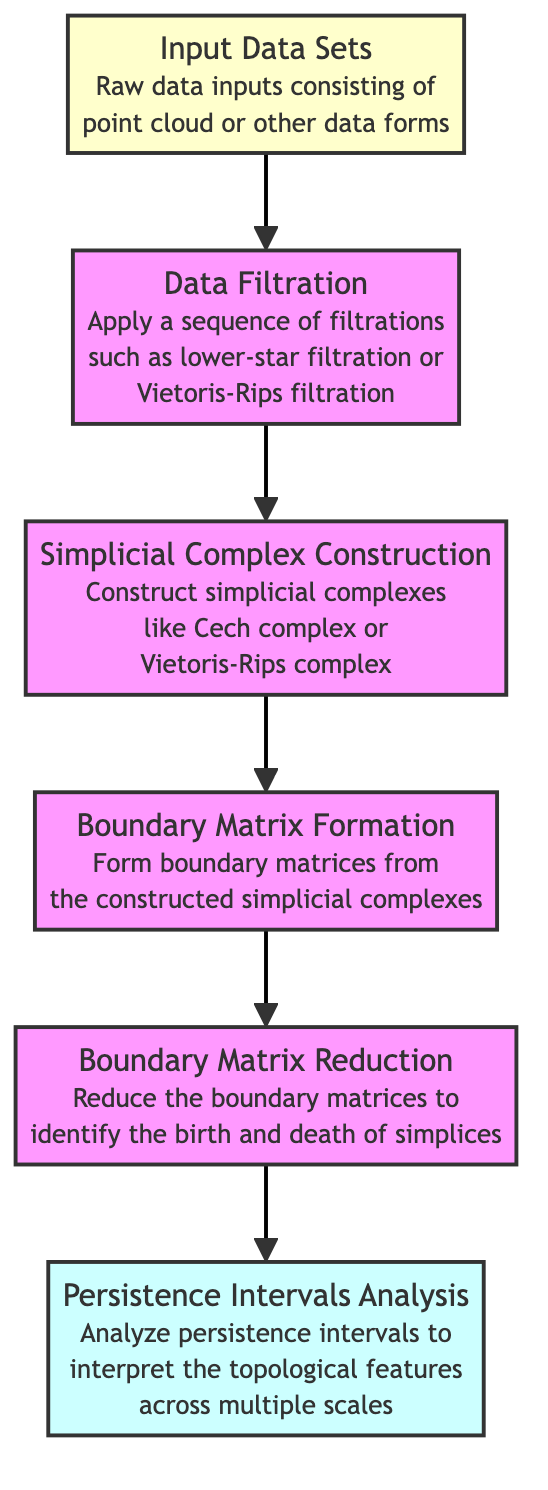What is the first node in the flowchart? The first node in the flowchart is labeled "Input Data Sets", which indicates the beginning of the algorithm's process.
Answer: Input Data Sets How many nodes are present in the diagram? By counting the distinct points labeled in the flowchart, there are six nodes in total: Input Data Sets, Data Filtration, Simplicial Complex Construction, Boundary Matrix Formation, Boundary Matrix Reduction, and Persistence Intervals Analysis.
Answer: 6 What type of filtration is applied in the second node? The second node describes "Data Filtration", specifying that a sequence of filtrations such as lower-star filtration or Vietoris-Rips filtration is applied to the input data sets.
Answer: Lower-star filtration or Vietoris-Rips filtration Which node comes after the "Boundary Matrix Formation"? The flowchart clearly indicates that the node following "Boundary Matrix Formation" is "Boundary Matrix Reduction." This shows the sequential process in the algorithm progression.
Answer: Boundary Matrix Reduction What is the purpose of the last node in the flowchart? The last node, labeled "Persistence Intervals Analysis," describes the analysis of persistence intervals to interpret topological features across multiple scales, highlighting its final analytical role in the algorithm.
Answer: Analyze persistence intervals What is the relationship between "Simplicial Complex Construction" and "Boundary Matrix Formation"? The flowchart displays a direct connection from the "Simplicial Complex Construction" node to the "Boundary Matrix Formation" node, indicating that the output of the former is needed to construct the latter. The transformation follows the sequence of operations in the algorithm.
Answer: Transformative relationship (output to input) How many edges connect the nodes in the diagram? By counting the directional arrows connecting each node, there are five edges in total, establishing a flow from one operation to the next throughout the diagram.
Answer: 5 What is formed from the simplicial complexes according to the flowchart? The flowchart explicitly states that "Boundary Matrix Formation" occurs, which indicates that boundary matrices are constructed from the simplicial complexes that were previously formed.
Answer: Boundary matrices Why is boundary matrix reduction important? According to the diagram, "Boundary Matrix Reduction" is crucial because it reduces the boundary matrices to identify the birth and death of simplices, which is fundamental in understanding the topology of the data.
Answer: Identify birth and death of simplices 